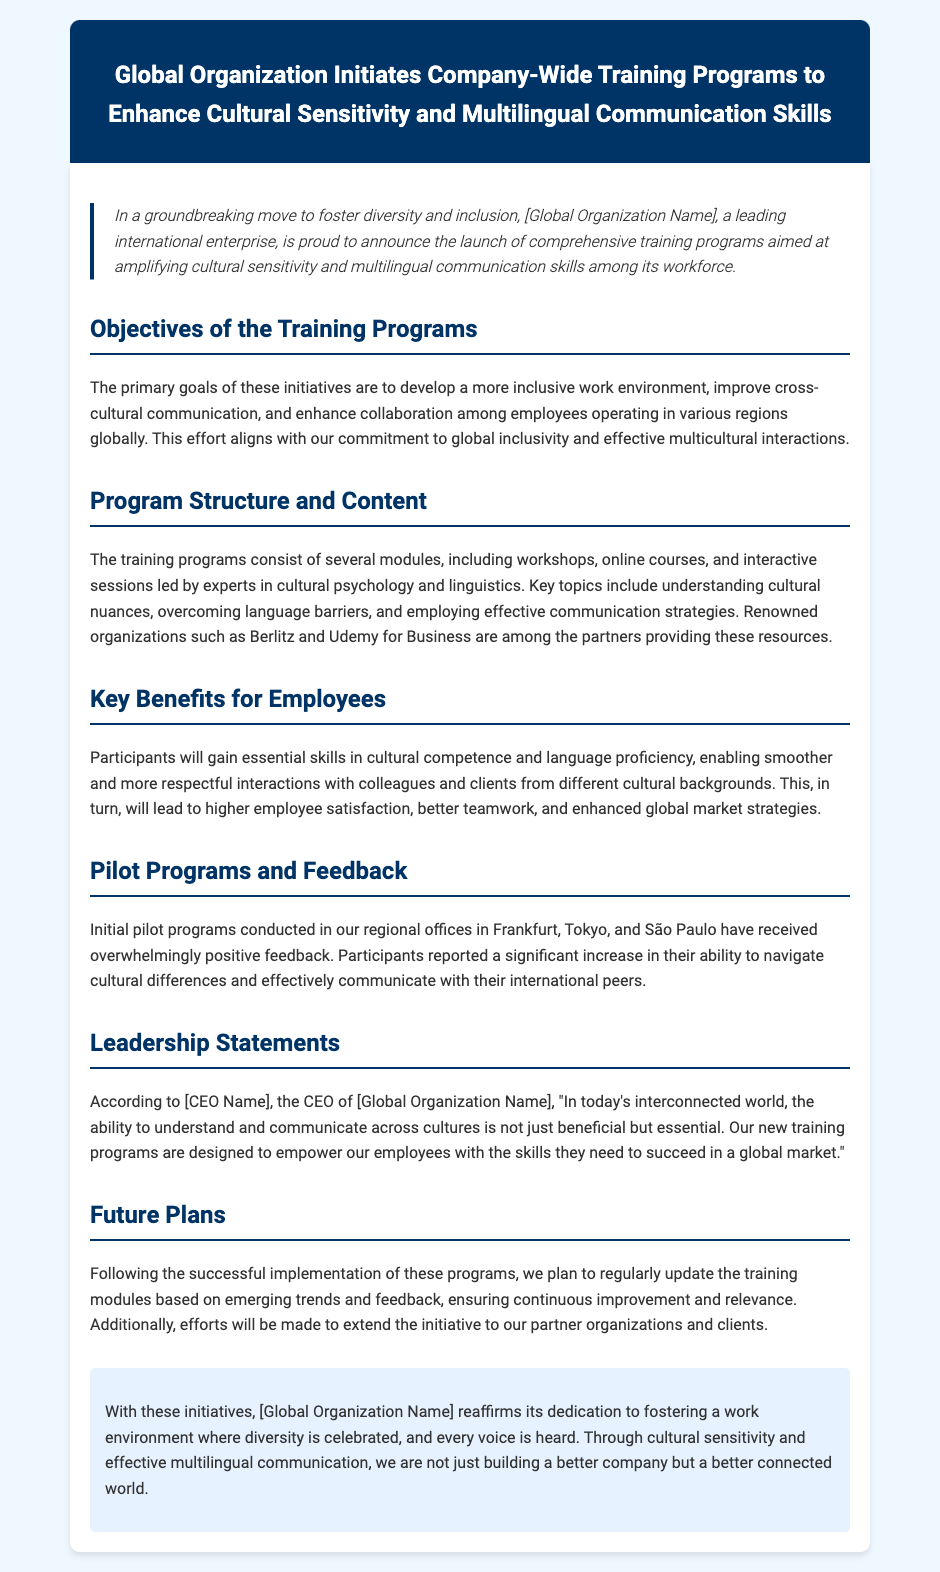What are the primary goals of the training programs? The primary goals are to develop a more inclusive work environment, improve cross-cultural communication, and enhance collaboration among employees.
Answer: inclusive work environment, cross-cultural communication, enhance collaboration Who is providing resources for the training programs? Renowned organizations such as Berlitz and Udemy for Business are partners providing these resources.
Answer: Berlitz and Udemy for Business What was the feedback from the pilot programs in regional offices? Participants reported a significant increase in their ability to navigate cultural differences and effectively communicate with their international peers.
Answer: significant increase What is the quote from the CEO regarding the training programs? The quote emphasizes the essential nature of understanding and communicating across cultures in today’s interconnected world.
Answer: essential What will be done to ensure continuous improvement of the training modules? The modules will be regularly updated based on emerging trends and feedback.
Answer: regularly updated 